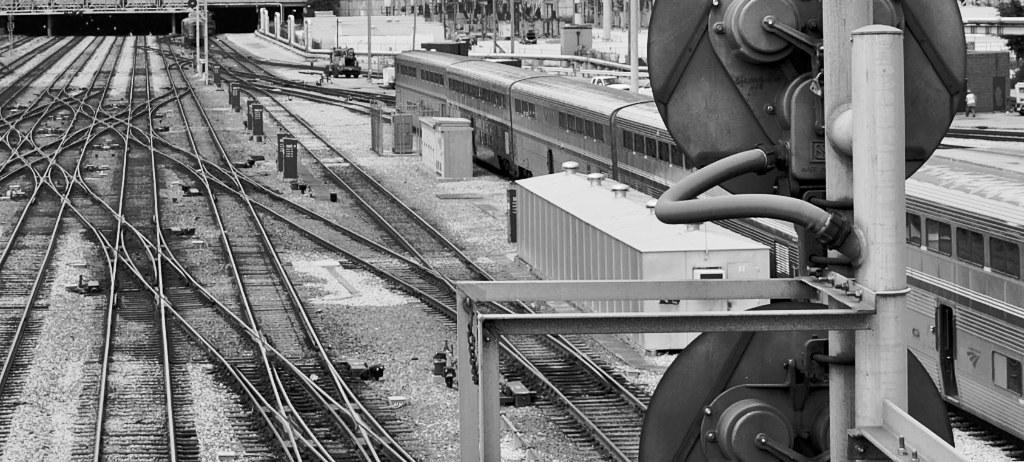In one or two sentences, can you explain what this image depicts? On the left side these are the railway tracks and on the right side there is a train. 